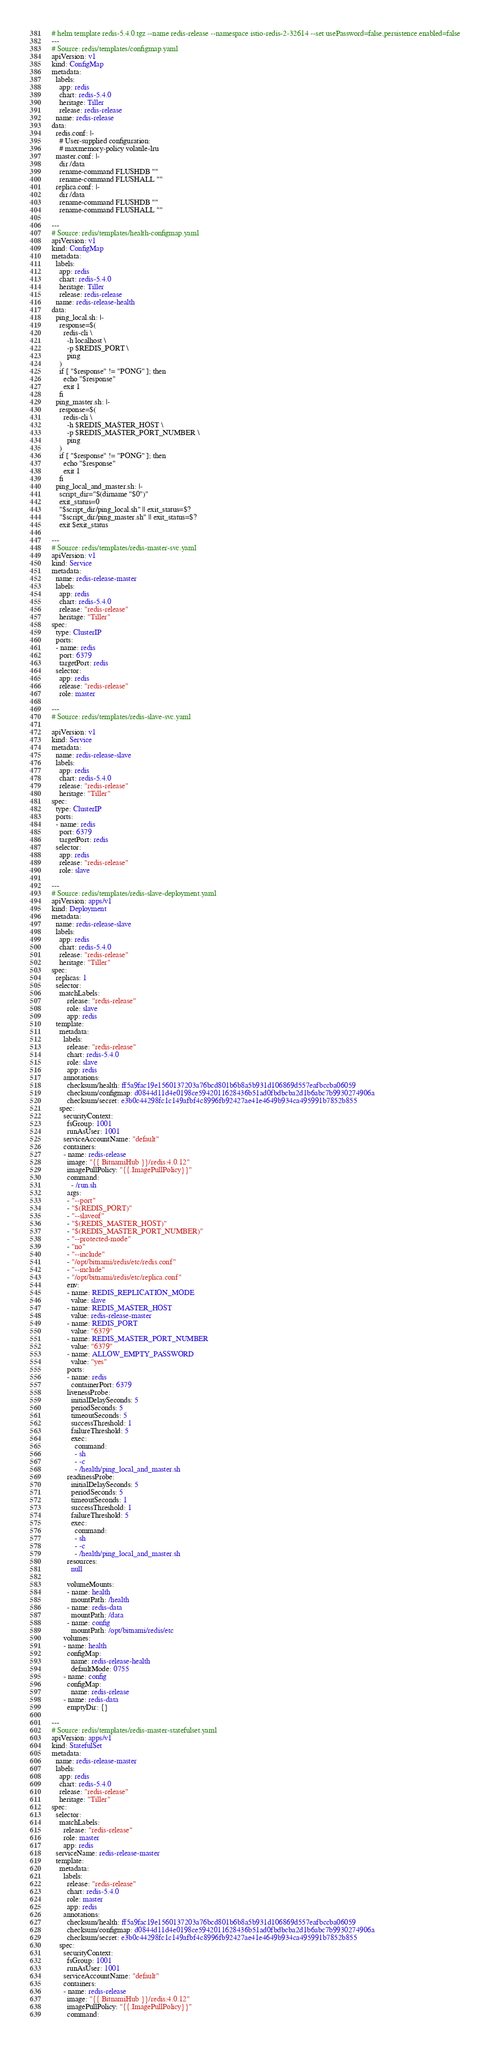<code> <loc_0><loc_0><loc_500><loc_500><_YAML_># helm template redis-5.4.0.tgz --name redis-release --namespace istio-redis-2-32614 --set usePassword=false,persistence.enabled=false
---
# Source: redis/templates/configmap.yaml
apiVersion: v1
kind: ConfigMap
metadata:
  labels:
    app: redis
    chart: redis-5.4.0
    heritage: Tiller
    release: redis-release
  name: redis-release
data:
  redis.conf: |-
    # User-supplied configuration:
    # maxmemory-policy volatile-lru
  master.conf: |-
    dir /data
    rename-command FLUSHDB ""
    rename-command FLUSHALL ""
  replica.conf: |-
    dir /data
    rename-command FLUSHDB ""
    rename-command FLUSHALL ""

---
# Source: redis/templates/health-configmap.yaml
apiVersion: v1
kind: ConfigMap
metadata:
  labels:
    app: redis
    chart: redis-5.4.0
    heritage: Tiller
    release: redis-release
  name: redis-release-health
data:
  ping_local.sh: |-
    response=$(
      redis-cli \
        -h localhost \
        -p $REDIS_PORT \
        ping
    )
    if [ "$response" != "PONG" ]; then
      echo "$response"
      exit 1
    fi
  ping_master.sh: |-
    response=$(
      redis-cli \
        -h $REDIS_MASTER_HOST \
        -p $REDIS_MASTER_PORT_NUMBER \
        ping
    )
    if [ "$response" != "PONG" ]; then
      echo "$response"
      exit 1
    fi
  ping_local_and_master.sh: |-
    script_dir="$(dirname "$0")"
    exit_status=0
    "$script_dir/ping_local.sh" || exit_status=$?
    "$script_dir/ping_master.sh" || exit_status=$?
    exit $exit_status

---
# Source: redis/templates/redis-master-svc.yaml
apiVersion: v1
kind: Service
metadata:
  name: redis-release-master
  labels:
    app: redis
    chart: redis-5.4.0
    release: "redis-release"
    heritage: "Tiller"
spec:
  type: ClusterIP
  ports:
  - name: redis
    port: 6379
    targetPort: redis
  selector:
    app: redis
    release: "redis-release"
    role: master

---
# Source: redis/templates/redis-slave-svc.yaml

apiVersion: v1
kind: Service
metadata:
  name: redis-release-slave
  labels:
    app: redis
    chart: redis-5.4.0
    release: "redis-release"
    heritage: "Tiller"
spec:
  type: ClusterIP
  ports:
  - name: redis
    port: 6379
    targetPort: redis
  selector:
    app: redis
    release: "redis-release"
    role: slave

---
# Source: redis/templates/redis-slave-deployment.yaml
apiVersion: apps/v1
kind: Deployment
metadata:
  name: redis-release-slave
  labels:
    app: redis
    chart: redis-5.4.0
    release: "redis-release"
    heritage: "Tiller"
spec:
  replicas: 1
  selector:
    matchLabels:
        release: "redis-release"
        role: slave
        app: redis
  template:
    metadata:
      labels:
        release: "redis-release"
        chart: redis-5.4.0
        role: slave
        app: redis
      annotations:
        checksum/health: ff5a9fac19e1560137203a76bcd801b6b8a5b931d106869d557eafbccba06059
        checksum/configmap: d0844d11d4e0198ce5942011628436b51ad0fbdbcba2d1b6abc7b9930274906a
        checksum/secret: e3b0c44298fc1c149afbf4c8996fb92427ae41e4649b934ca495991b7852b855
    spec:      
      securityContext:
        fsGroup: 1001
        runAsUser: 1001
      serviceAccountName: "default"
      containers:
      - name: redis-release
        image: "{{ BitnamiHub }}/redis:4.0.12"
        imagePullPolicy: "{{.ImagePullPolicy}}"
        command:
          - /run.sh
        args:
        - "--port"
        - "$(REDIS_PORT)"
        - "--slaveof"
        - "$(REDIS_MASTER_HOST)"
        - "$(REDIS_MASTER_PORT_NUMBER)"
        - "--protected-mode"
        - "no"
        - "--include"
        - "/opt/bitnami/redis/etc/redis.conf"
        - "--include"
        - "/opt/bitnami/redis/etc/replica.conf"
        env:
        - name: REDIS_REPLICATION_MODE
          value: slave
        - name: REDIS_MASTER_HOST
          value: redis-release-master
        - name: REDIS_PORT
          value: "6379"
        - name: REDIS_MASTER_PORT_NUMBER
          value: "6379"
        - name: ALLOW_EMPTY_PASSWORD
          value: "yes"
        ports:
        - name: redis
          containerPort: 6379        
        livenessProbe:
          initialDelaySeconds: 5
          periodSeconds: 5
          timeoutSeconds: 5
          successThreshold: 1
          failureThreshold: 5
          exec:
            command:
            - sh
            - -c
            - /health/ping_local_and_master.sh        
        readinessProbe:
          initialDelaySeconds: 5
          periodSeconds: 5
          timeoutSeconds: 1
          successThreshold: 1
          failureThreshold: 5
          exec:
            command:
            - sh
            - -c
            - /health/ping_local_and_master.sh
        resources:
          null
          
        volumeMounts:
        - name: health
          mountPath: /health
        - name: redis-data
          mountPath: /data
        - name: config
          mountPath: /opt/bitnami/redis/etc
      volumes:
      - name: health
        configMap:
          name: redis-release-health
          defaultMode: 0755
      - name: config
        configMap:
          name: redis-release
      - name: redis-data
        emptyDir: {}

---
# Source: redis/templates/redis-master-statefulset.yaml
apiVersion: apps/v1
kind: StatefulSet
metadata:
  name: redis-release-master
  labels:
    app: redis
    chart: redis-5.4.0
    release: "redis-release"
    heritage: "Tiller"
spec:
  selector:
    matchLabels:
      release: "redis-release"
      role: master
      app: redis
  serviceName: redis-release-master
  template:
    metadata:
      labels:
        release: "redis-release"
        chart: redis-5.4.0
        role: master
        app: redis
      annotations:
        checksum/health: ff5a9fac19e1560137203a76bcd801b6b8a5b931d106869d557eafbccba06059
        checksum/configmap: d0844d11d4e0198ce5942011628436b51ad0fbdbcba2d1b6abc7b9930274906a
        checksum/secret: e3b0c44298fc1c149afbf4c8996fb92427ae41e4649b934ca495991b7852b855
    spec:
      securityContext:
        fsGroup: 1001
        runAsUser: 1001
      serviceAccountName: "default"
      containers:
      - name: redis-release
        image: "{{ BitnamiHub }}/redis:4.0.12"
        imagePullPolicy: "{{.ImagePullPolicy}}"
        command:</code> 